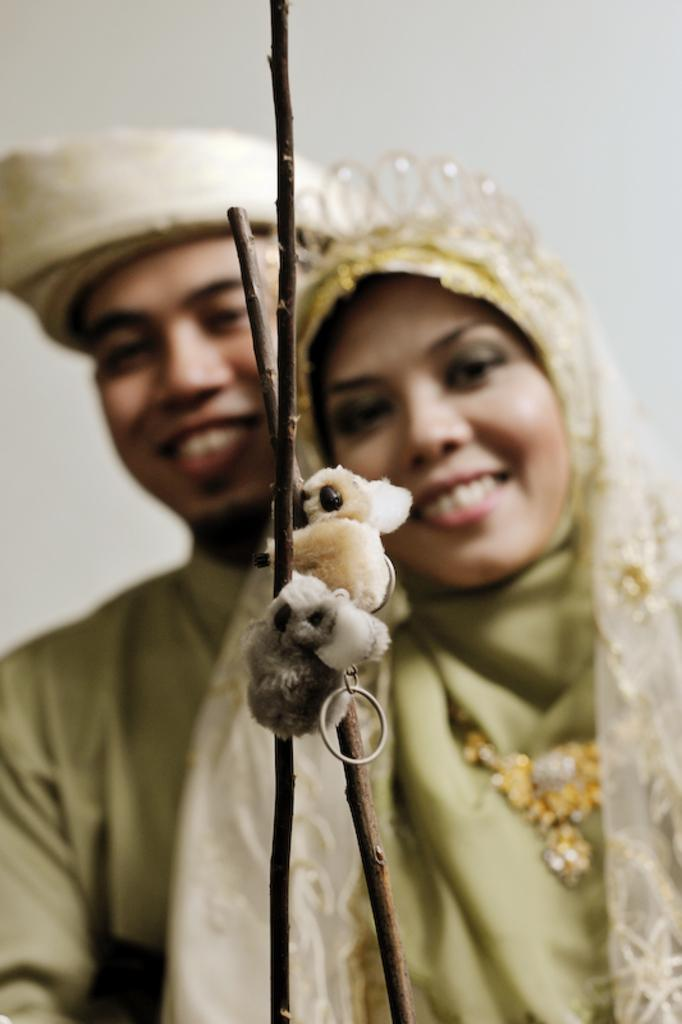What objects are featured in the image? There are key chains in the image. How are the key chains displayed? The key chains are attached to wooden sticks. Can you describe the background of the image? The background of the image is slightly blurred, and there is a white color wall. Are there any people visible in the image? Yes, a man and a woman are standing in the background. How many ants are crawling on the key chains in the image? There are no ants present in the image; it only features key chains attached to wooden sticks. What type of zebra can be seen in the background of the image? There is no zebra present in the image; the background features a white color wall and a man and a woman standing in front of it. 